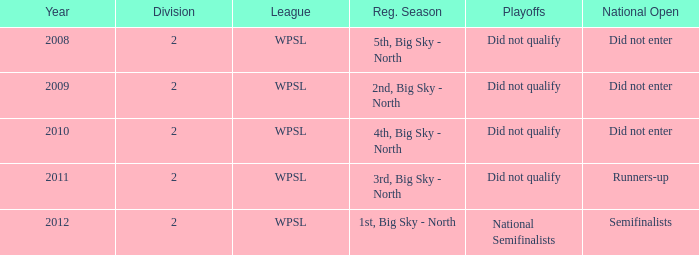Give me the full table as a dictionary. {'header': ['Year', 'Division', 'League', 'Reg. Season', 'Playoffs', 'National Open'], 'rows': [['2008', '2', 'WPSL', '5th, Big Sky - North', 'Did not qualify', 'Did not enter'], ['2009', '2', 'WPSL', '2nd, Big Sky - North', 'Did not qualify', 'Did not enter'], ['2010', '2', 'WPSL', '4th, Big Sky - North', 'Did not qualify', 'Did not enter'], ['2011', '2', 'WPSL', '3rd, Big Sky - North', 'Did not qualify', 'Runners-up'], ['2012', '2', 'WPSL', '1st, Big Sky - North', 'National Semifinalists', 'Semifinalists']]} What was the regular season name where they did not qualify for the playoffs in 2009? 2nd, Big Sky - North. 